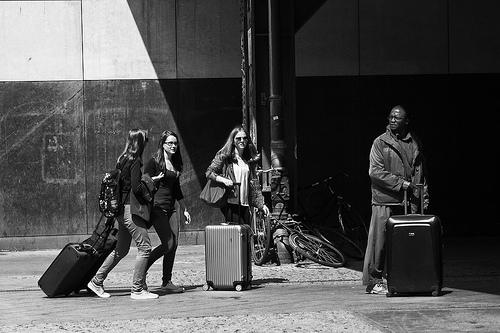Question: what are the people doing?
Choices:
A. Dancing.
B. Eating.
C. Skiing.
D. Walking.
Answer with the letter. Answer: D Question: what are the ladies looking through?
Choices:
A. Glasses.
B. Binoculars.
C. Window.
D. Fence posts.
Answer with the letter. Answer: A Question: when was photo taken?
Choices:
A. Nighttime.
B. Daytime.
C. Sunset.
D. Morning.
Answer with the letter. Answer: B Question: what is in black and white?
Choices:
A. Police car.
B. Airplane.
C. This picture.
D. Roadway.
Answer with the letter. Answer: C Question: who is in front?
Choices:
A. A woman.
B. A little boy.
C. A man.
D. A little girl.
Answer with the letter. Answer: C Question: where is this picture taken?
Choices:
A. Office.
B. Soccer stadium.
C. Marina.
D. Parking lot.
Answer with the letter. Answer: D Question: how many suitcases are there?
Choices:
A. Two.
B. Three.
C. Four.
D. Five.
Answer with the letter. Answer: B 